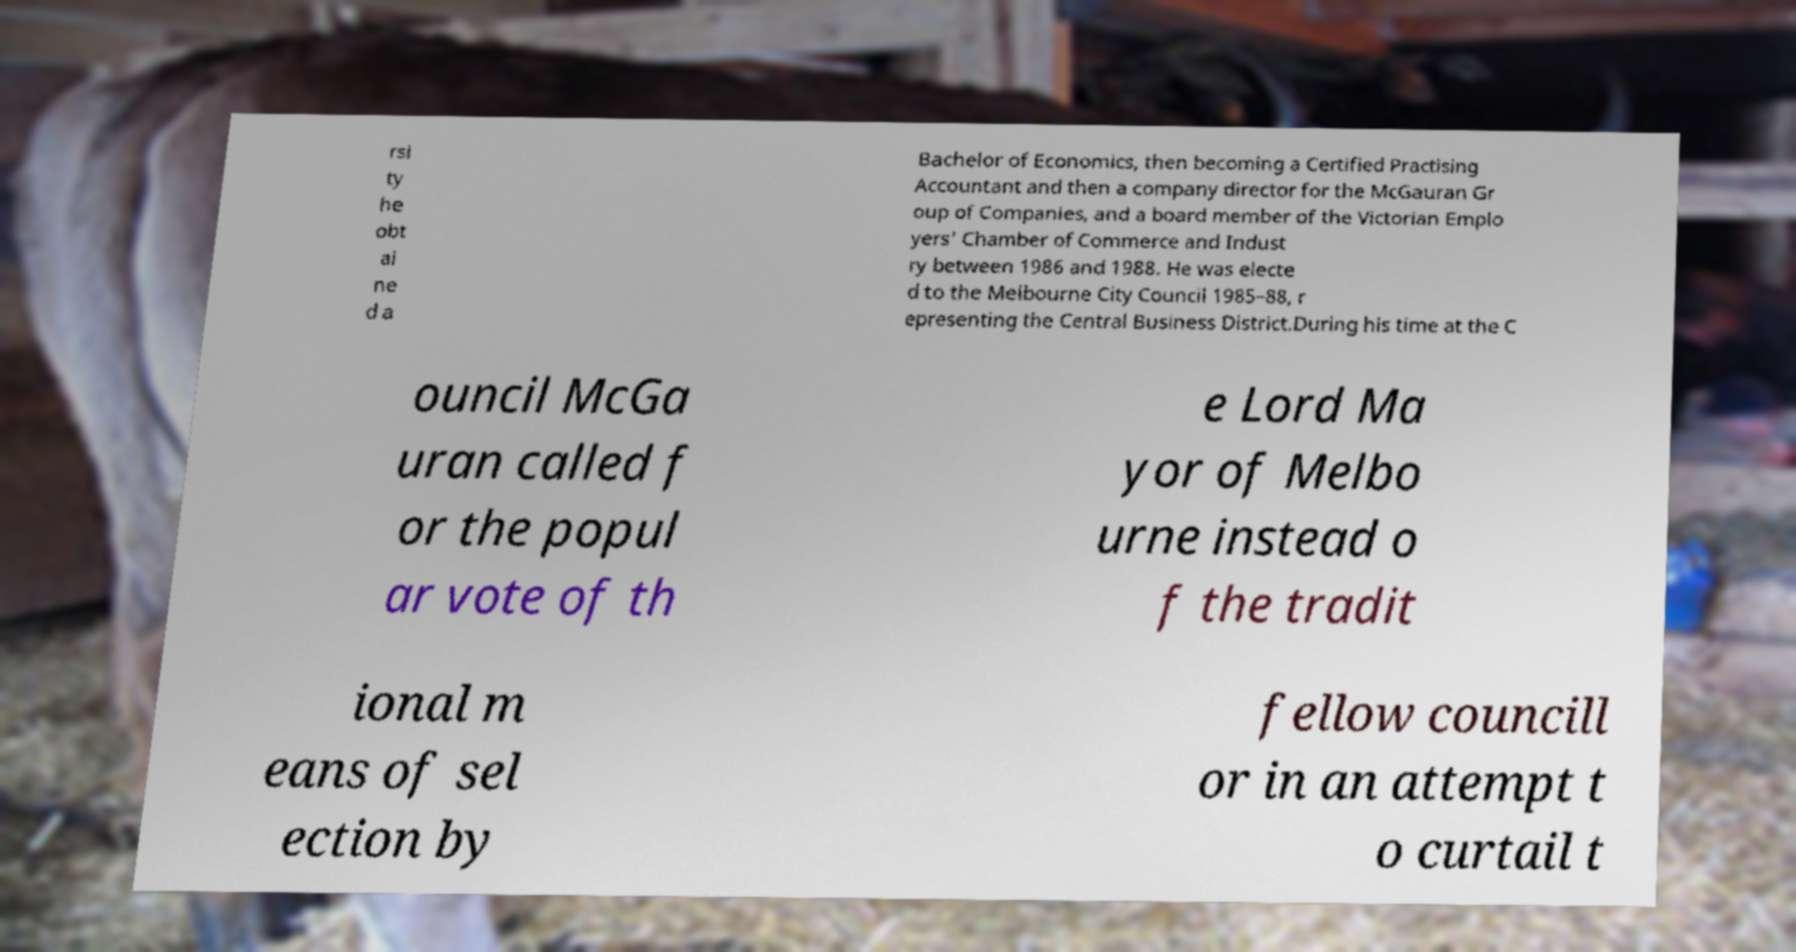What messages or text are displayed in this image? I need them in a readable, typed format. rsi ty he obt ai ne d a Bachelor of Economics, then becoming a Certified Practising Accountant and then a company director for the McGauran Gr oup of Companies, and a board member of the Victorian Emplo yers' Chamber of Commerce and Indust ry between 1986 and 1988. He was electe d to the Melbourne City Council 1985–88, r epresenting the Central Business District.During his time at the C ouncil McGa uran called f or the popul ar vote of th e Lord Ma yor of Melbo urne instead o f the tradit ional m eans of sel ection by fellow councill or in an attempt t o curtail t 